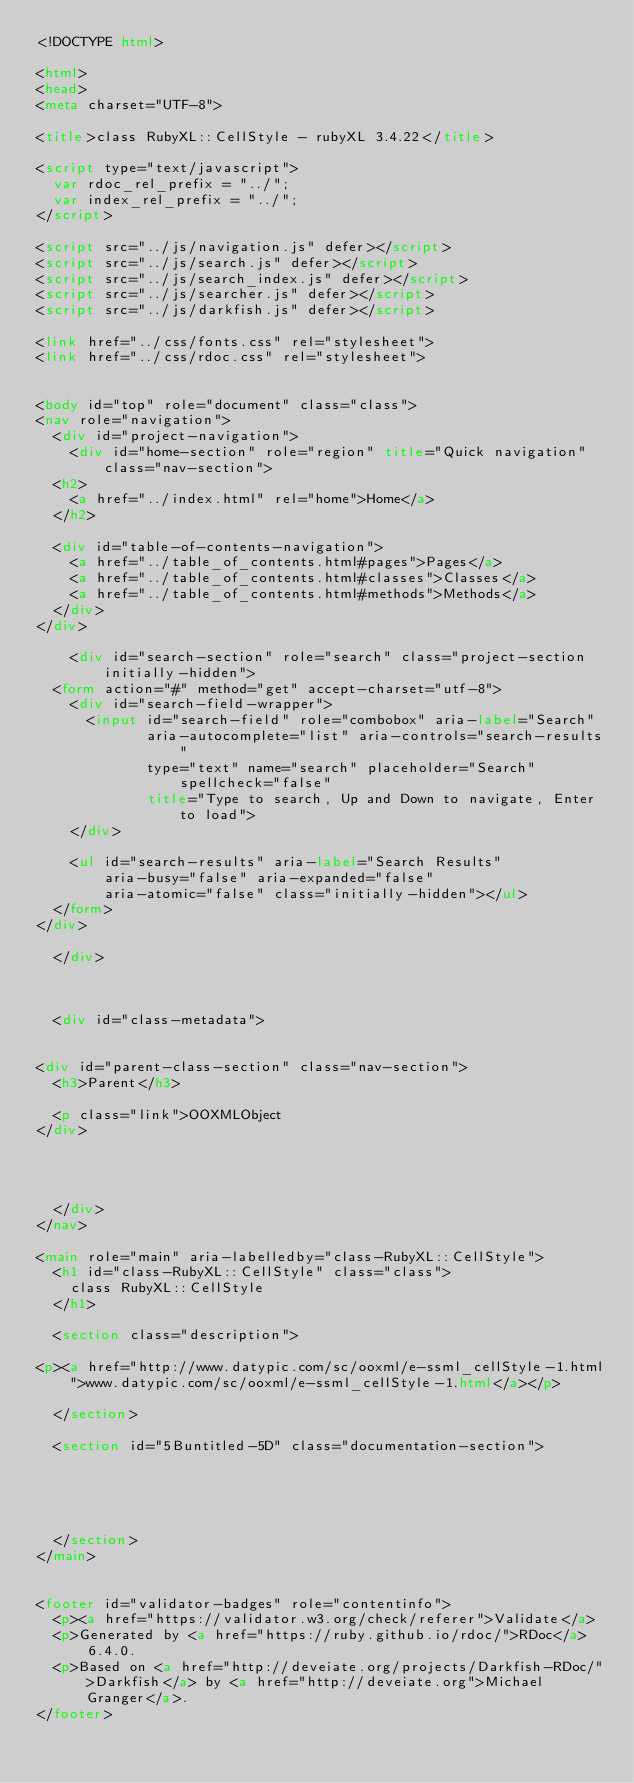Convert code to text. <code><loc_0><loc_0><loc_500><loc_500><_HTML_><!DOCTYPE html>

<html>
<head>
<meta charset="UTF-8">

<title>class RubyXL::CellStyle - rubyXL 3.4.22</title>

<script type="text/javascript">
  var rdoc_rel_prefix = "../";
  var index_rel_prefix = "../";
</script>

<script src="../js/navigation.js" defer></script>
<script src="../js/search.js" defer></script>
<script src="../js/search_index.js" defer></script>
<script src="../js/searcher.js" defer></script>
<script src="../js/darkfish.js" defer></script>

<link href="../css/fonts.css" rel="stylesheet">
<link href="../css/rdoc.css" rel="stylesheet">


<body id="top" role="document" class="class">
<nav role="navigation">
  <div id="project-navigation">
    <div id="home-section" role="region" title="Quick navigation" class="nav-section">
  <h2>
    <a href="../index.html" rel="home">Home</a>
  </h2>

  <div id="table-of-contents-navigation">
    <a href="../table_of_contents.html#pages">Pages</a>
    <a href="../table_of_contents.html#classes">Classes</a>
    <a href="../table_of_contents.html#methods">Methods</a>
  </div>
</div>

    <div id="search-section" role="search" class="project-section initially-hidden">
  <form action="#" method="get" accept-charset="utf-8">
    <div id="search-field-wrapper">
      <input id="search-field" role="combobox" aria-label="Search"
             aria-autocomplete="list" aria-controls="search-results"
             type="text" name="search" placeholder="Search" spellcheck="false"
             title="Type to search, Up and Down to navigate, Enter to load">
    </div>

    <ul id="search-results" aria-label="Search Results"
        aria-busy="false" aria-expanded="false"
        aria-atomic="false" class="initially-hidden"></ul>
  </form>
</div>

  </div>

  

  <div id="class-metadata">
    
    
<div id="parent-class-section" class="nav-section">
  <h3>Parent</h3>

  <p class="link">OOXMLObject
</div>

    
    
    
  </div>
</nav>

<main role="main" aria-labelledby="class-RubyXL::CellStyle">
  <h1 id="class-RubyXL::CellStyle" class="class">
    class RubyXL::CellStyle
  </h1>

  <section class="description">
    
<p><a href="http://www.datypic.com/sc/ooxml/e-ssml_cellStyle-1.html">www.datypic.com/sc/ooxml/e-ssml_cellStyle-1.html</a></p>

  </section>

  <section id="5Buntitled-5D" class="documentation-section">





  </section>
</main>


<footer id="validator-badges" role="contentinfo">
  <p><a href="https://validator.w3.org/check/referer">Validate</a>
  <p>Generated by <a href="https://ruby.github.io/rdoc/">RDoc</a> 6.4.0.
  <p>Based on <a href="http://deveiate.org/projects/Darkfish-RDoc/">Darkfish</a> by <a href="http://deveiate.org">Michael Granger</a>.
</footer>

</code> 